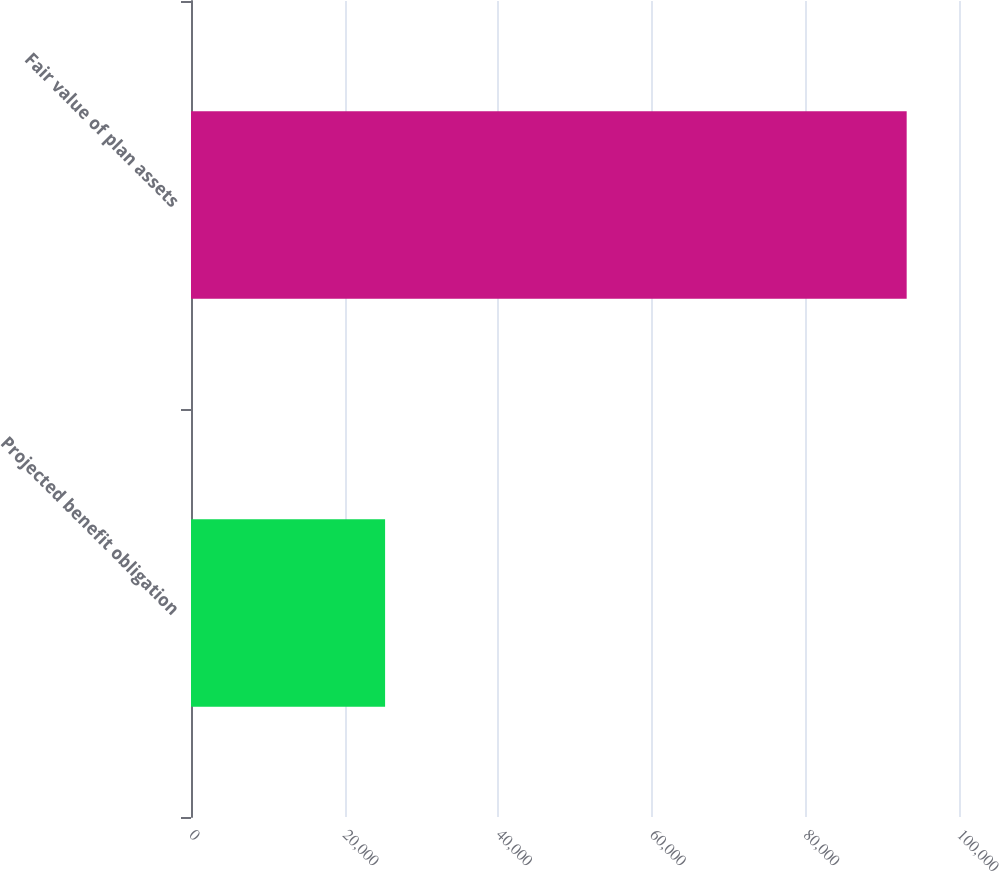Convert chart. <chart><loc_0><loc_0><loc_500><loc_500><bar_chart><fcel>Projected benefit obligation<fcel>Fair value of plan assets<nl><fcel>25272<fcel>93187<nl></chart> 